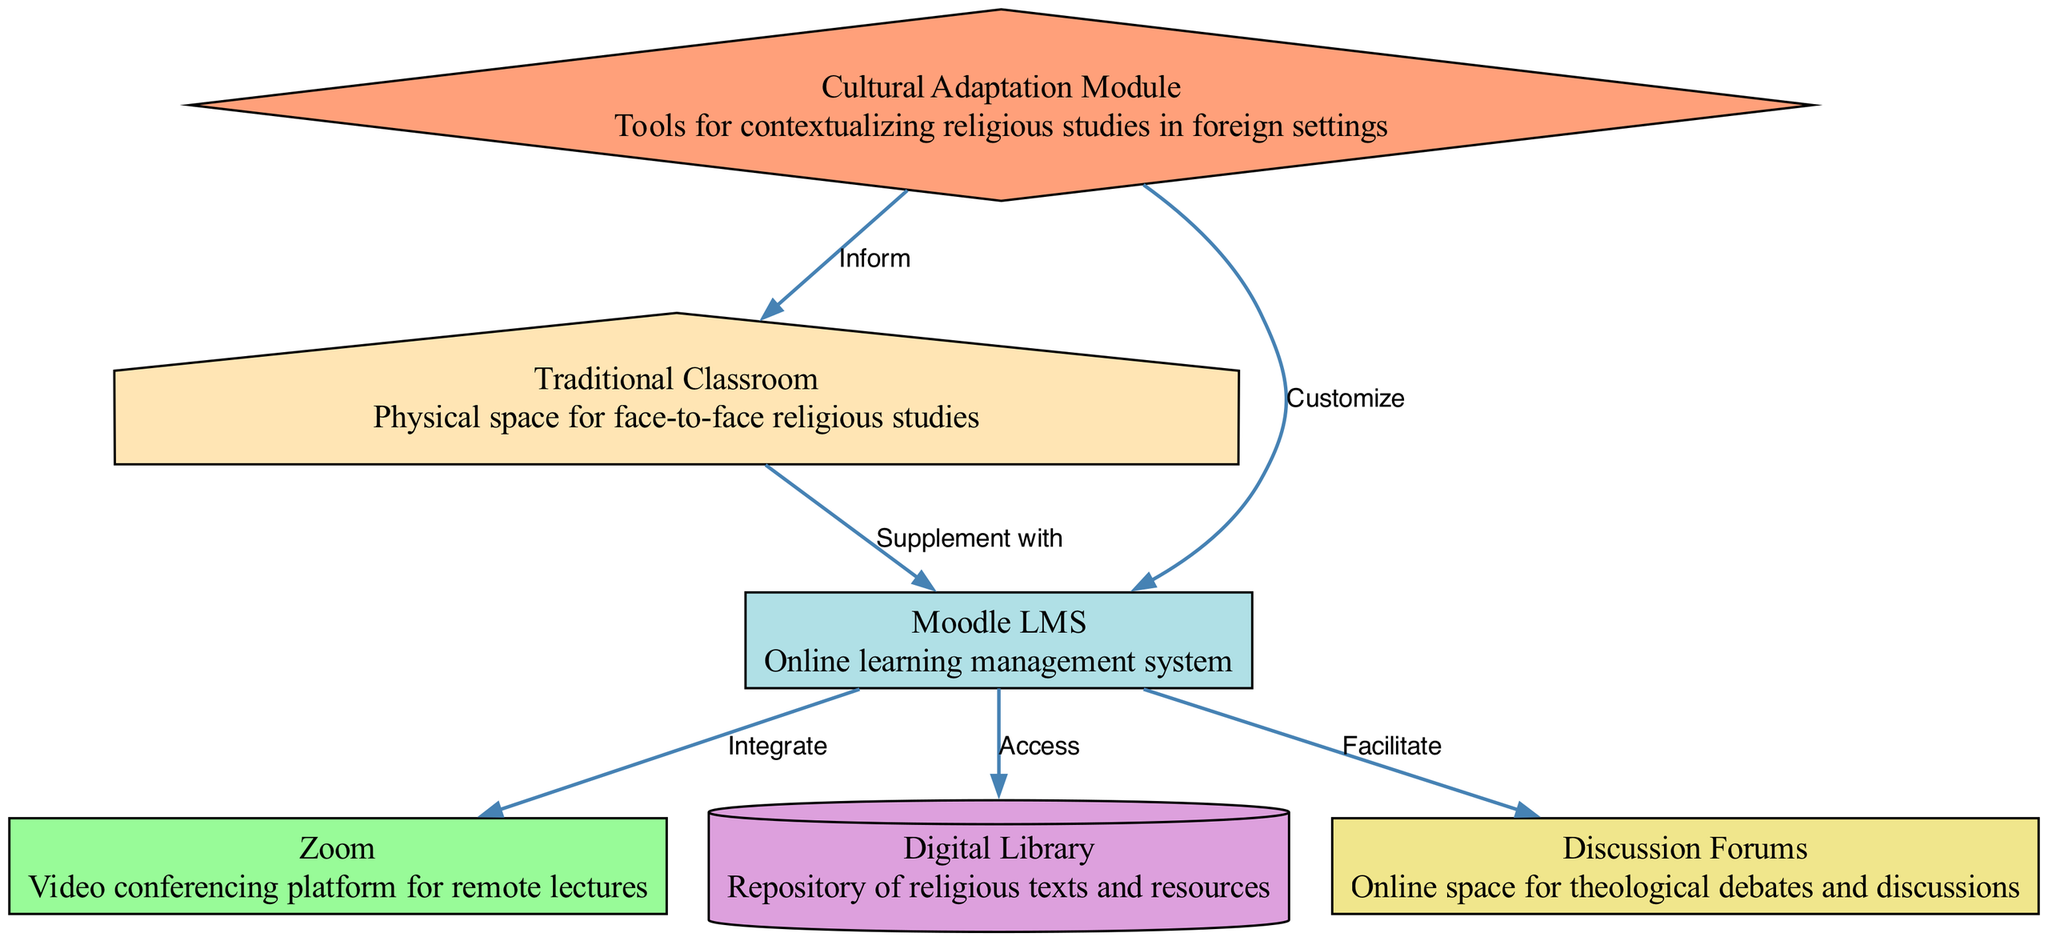What are the nodes present in the diagram? The nodes in the diagram include Traditional Classroom, Moodle LMS, Zoom, Digital Library, Discussion Forums, and Cultural Adaptation Module. A quick review of the node section will reveal these entities, each representing a different component of the system architecture.
Answer: Traditional Classroom, Moodle LMS, Zoom, Digital Library, Discussion Forums, Cultural Adaptation Module How many edges are there in total? By counting the connections made from one node to another, the diagram shows six distinct edges that illustrate the relationships between various components. Careful inspection reveals each edge's line connecting two node identifiers.
Answer: 6 What does the edge between Moodle LMS and Discussion Forums signify? The edge from Moodle LMS to Discussion Forums is labeled as "Facilitate," indicating that Moodle LMS plays a role in enabling or supporting discussions within the Discussion Forums, which enhances the collaborative aspect of religious studies.
Answer: Facilitate What role does the Cultural Adaptation Module play in the Traditional Classroom? The edge from Cultural Adaptation Module to Traditional Classroom is labeled "Inform," which implies that this module provides essential knowledge or resources that guide the teaching methods in a traditional setting, aiding in contextualization.
Answer: Inform What type of diagram is this? This represents an Engineering Diagram that illustrates the architecture of a system integrating online learning platforms with traditional methods of teaching religious studies. The structured format showcases the relationships and roles within the system succinctly.
Answer: Engineering Diagram How does Moodle LMS integrate with Zoom? The edge from Moodle LMS to Zoom is labeled "Integrate," which indicates that Moodle LMS is designed to work in conjunction with Zoom to facilitate remote classes or lectures, thus enhancing the teaching experience.
Answer: Integrate What is the purpose of the Digital Library within Moodle LMS? The edge connecting Moodle LMS to Digital Library is marked as "Access," suggesting that users of Moodle LMS can retrieve or utilize resources available in the Digital Library, making theological content readily available for study.
Answer: Access How does the Cultural Adaptation Module customize Moodle LMS? The edge from Cultural Adaptation Module to Moodle LMS is labeled "Customize," which signifies that this module can tailor the online learning experience to better fit specific cultural contexts, ensuring relevance in diverse teaching environments.
Answer: Customize 